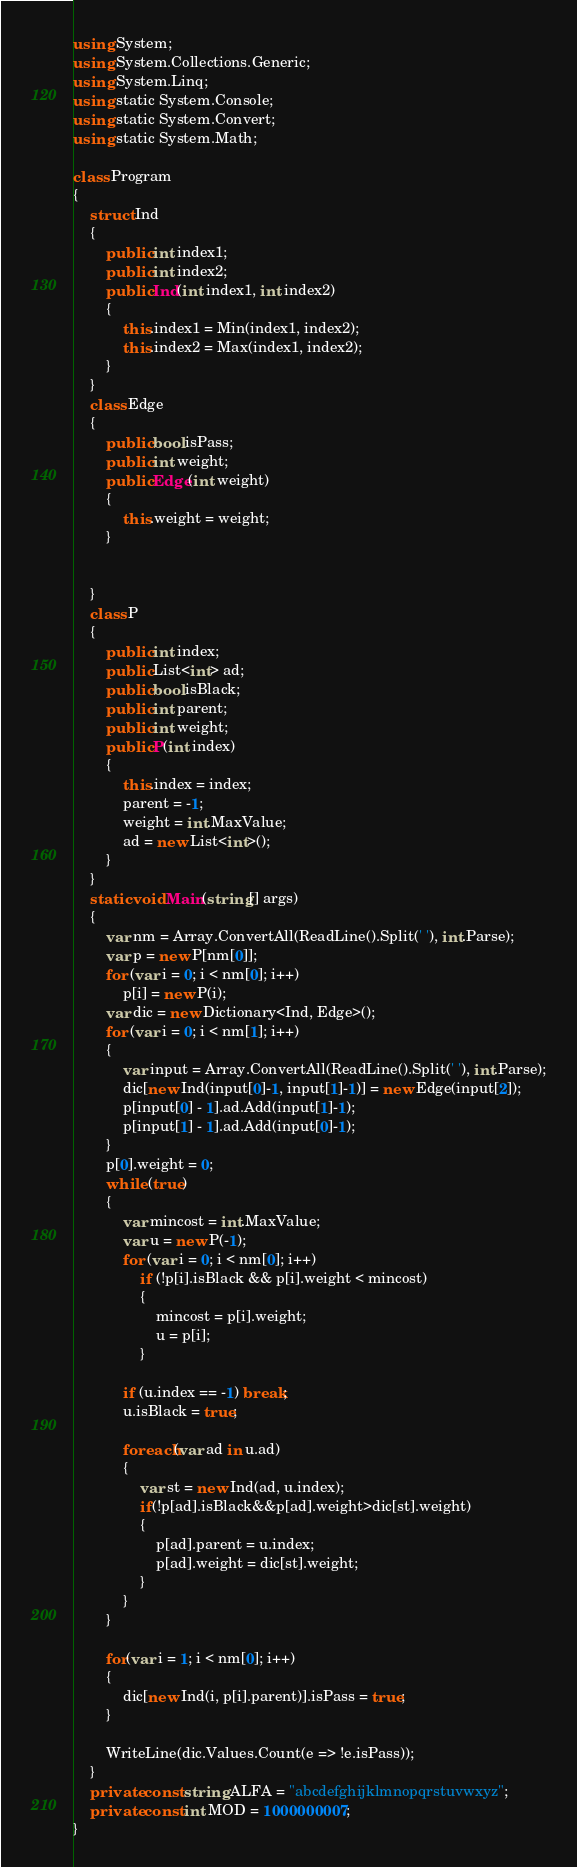<code> <loc_0><loc_0><loc_500><loc_500><_C#_>using System;
using System.Collections.Generic;
using System.Linq;
using static System.Console;
using static System.Convert;
using static System.Math;

class Program
{
    struct Ind
    {
        public int index1;
        public int index2;
        public Ind(int index1, int index2)
        {
            this.index1 = Min(index1, index2);
            this.index2 = Max(index1, index2);
        }
    }
    class Edge
    { 
        public bool isPass;
        public int weight;
        public Edge(int weight)
        {
            this.weight = weight;
        }

     
    }
    class P
    {
        public int index;
        public List<int> ad;
        public bool isBlack;
        public int parent;
        public int weight;
        public P(int index)
        {
            this.index = index;
            parent = -1;
            weight = int.MaxValue;
            ad = new List<int>();
        }
    }
    static void Main(string[] args)
    {
        var nm = Array.ConvertAll(ReadLine().Split(' '), int.Parse);
        var p = new P[nm[0]];
        for (var i = 0; i < nm[0]; i++)
            p[i] = new P(i);
        var dic = new Dictionary<Ind, Edge>();
        for (var i = 0; i < nm[1]; i++)
        {
            var input = Array.ConvertAll(ReadLine().Split(' '), int.Parse);
            dic[new Ind(input[0]-1, input[1]-1)] = new Edge(input[2]);
            p[input[0] - 1].ad.Add(input[1]-1);
            p[input[1] - 1].ad.Add(input[0]-1);
        }
        p[0].weight = 0;
        while (true)
        {
            var mincost = int.MaxValue;
            var u = new P(-1);
            for (var i = 0; i < nm[0]; i++)
                if (!p[i].isBlack && p[i].weight < mincost)
                {
                    mincost = p[i].weight;
                    u = p[i];
                }

            if (u.index == -1) break;
            u.isBlack = true;

            foreach(var ad in u.ad)
            {
                var st = new Ind(ad, u.index);
                if(!p[ad].isBlack&&p[ad].weight>dic[st].weight)
                {
                    p[ad].parent = u.index;
                    p[ad].weight = dic[st].weight;
                }
            }
        }
        
        for(var i = 1; i < nm[0]; i++)
        {
            dic[new Ind(i, p[i].parent)].isPass = true;
        }

        WriteLine(dic.Values.Count(e => !e.isPass));
    }
    private const string ALFA = "abcdefghijklmnopqrstuvwxyz";
    private const int MOD = 1000000007;
}
</code> 